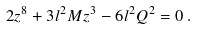<formula> <loc_0><loc_0><loc_500><loc_500>2 z ^ { 8 } + 3 l ^ { 2 } M z ^ { 3 } - 6 l ^ { 2 } Q ^ { 2 } = 0 \, .</formula> 